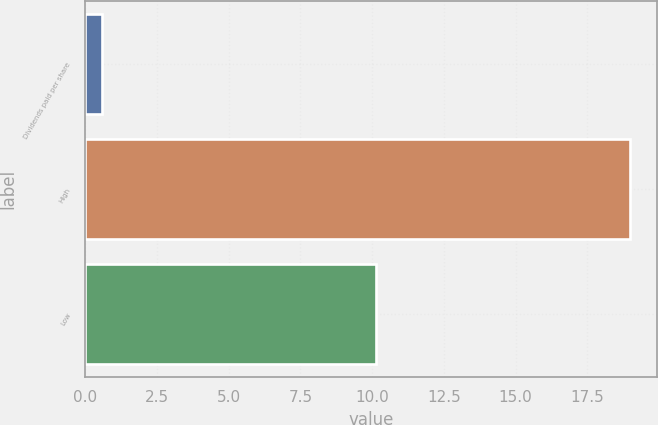Convert chart. <chart><loc_0><loc_0><loc_500><loc_500><bar_chart><fcel>Dividends paid per share<fcel>High<fcel>Low<nl><fcel>0.6<fcel>18.99<fcel>10.13<nl></chart> 